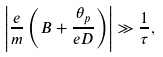<formula> <loc_0><loc_0><loc_500><loc_500>\left | \frac { e } { m } \left ( B + \frac { \theta _ { p } } { e D } \right ) \right | \gg \frac { 1 } { \tau } ,</formula> 